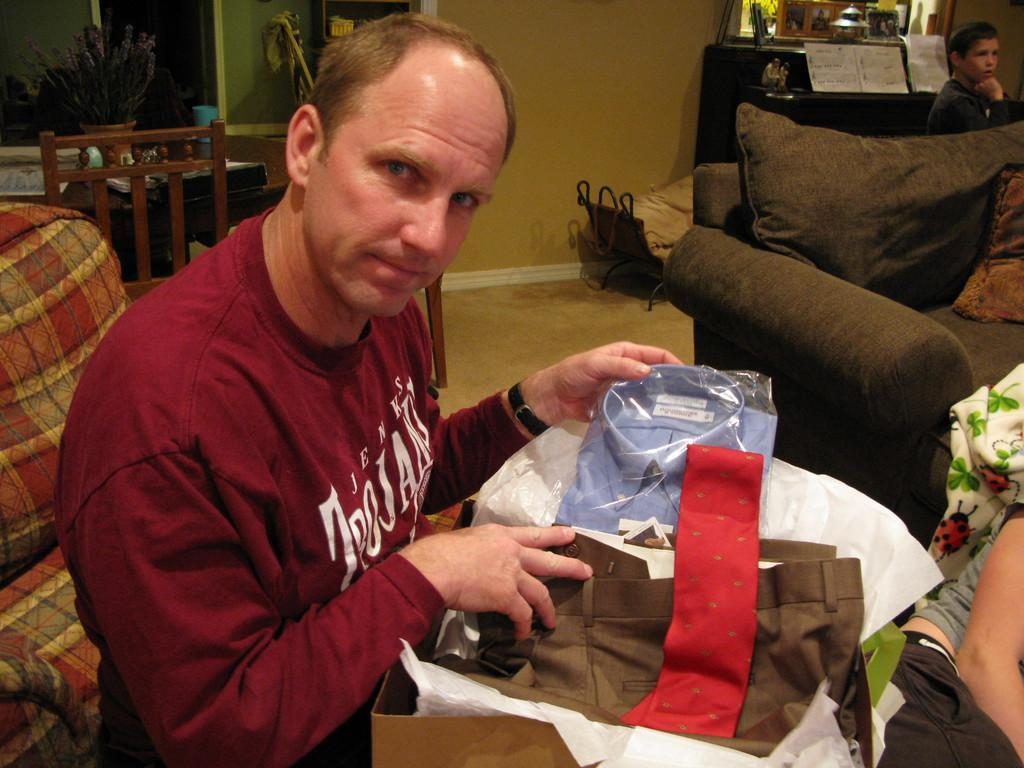What type of structure can be seen in the image? There is a wall in the image. What type of furniture is present in the image? There is a chair and a table in the image. What is the person in the image doing? The person is sitting on a sofa in the image. What items are related to clothing in the image? Clothes are present in the image. What type of container is visible in the image? There is a box in the image. How does the family's digestion process appear to be affected by the border in the image? There is no mention of a family, digestion, or border in the image. The image only contains a wall, a chair, a table, a person sitting on a sofa, clothes, and a box. 